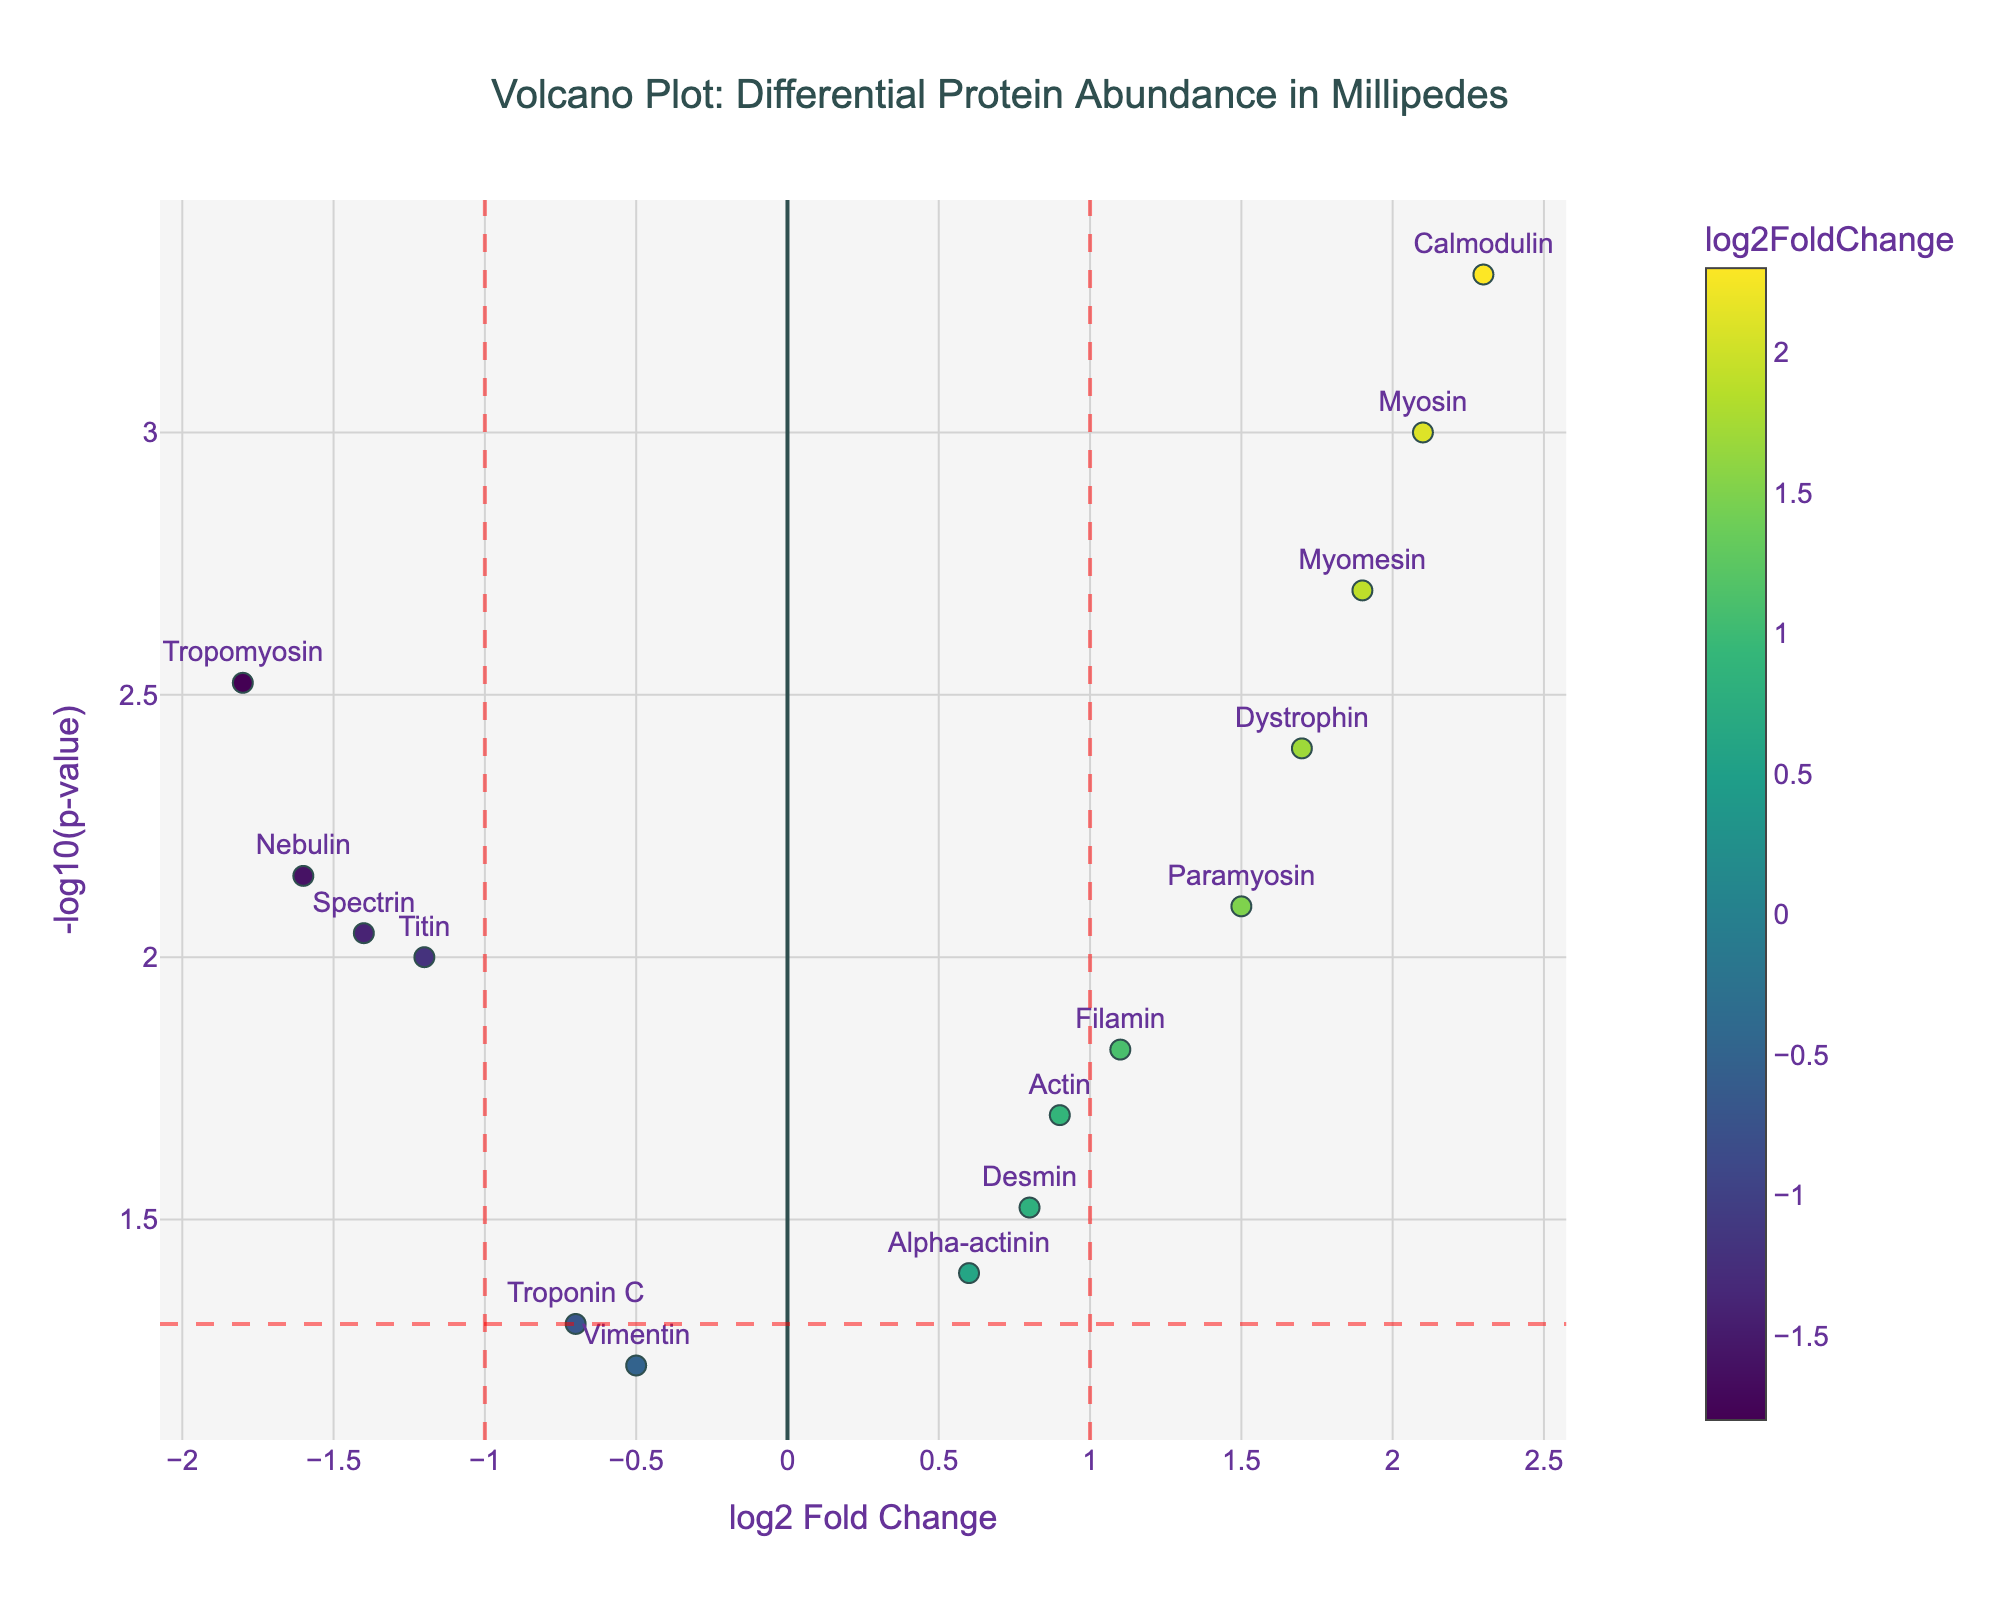What is the title of the plot? The title is positioned at the top center of the plot and states the main purpose and subject of the visualized data.
Answer: "Volcano Plot: Differential Protein Abundance in Millipedes" How many proteins have a positive log2 fold change above 1? By examining the plot, we identify points on the right side of the vertical red line at x=1. These points include Myosin, Dystrophin, Calmodulin, and Myomesin.
Answer: 4 Which protein has the smallest p-value? The smallest p-value corresponds to the highest y-value, which is -log10(p-value). Calmodulin achieves the highest y-position on the plot.
Answer: Calmodulin What is the fold change for Tropomyosin, and is it statistically significant? First, locate Tropomyosin on the plot with a log2 fold change of -1.8. Check if it lies above the red horizontal line (indicating p-value < 0.05, or -log10(p-value) > 1.3). Tropomyosin is indeed above this line.
Answer: -1.8, Yes Which proteins are located in the bottom right quadrant of the plot? Proteins in this quadrant have positive log2 fold changes and p-values greater than 0.05 (i.e., below the red horizontal line). Actin and Filamin are such proteins.
Answer: Actin, Filamin Identify the protein with the highest positive log2 fold change. Look for the rightmost data point on the plot. Calmodulin is the rightmost, indicating the highest positive log2 fold change.
Answer: Calmodulin Are there any proteins with their log2 fold change between -1 and 1 but with p-value less than 0.05? These proteins will be within the central vertical region (between x=-1 and x=1) and above the red horizontal line. Actin (0.9), Paramyosin (1.5), Myomesin (1.9), Desmin (0.8), Spectrin (-1.4) meet these criteria.
Answer: Actin, Paramyosin, Myomesin, Desmin, Spectrin What is the -log10(p-value) for Myomesin, and what can you deduce about its statistical significance? Identify Myomesin in the y dimension (calculated as -log10(0.002)). This value is higher than 1.3, indicating statistical significance. The y position approximately matches this value on the plot.
Answer: 2.69897, Significant 